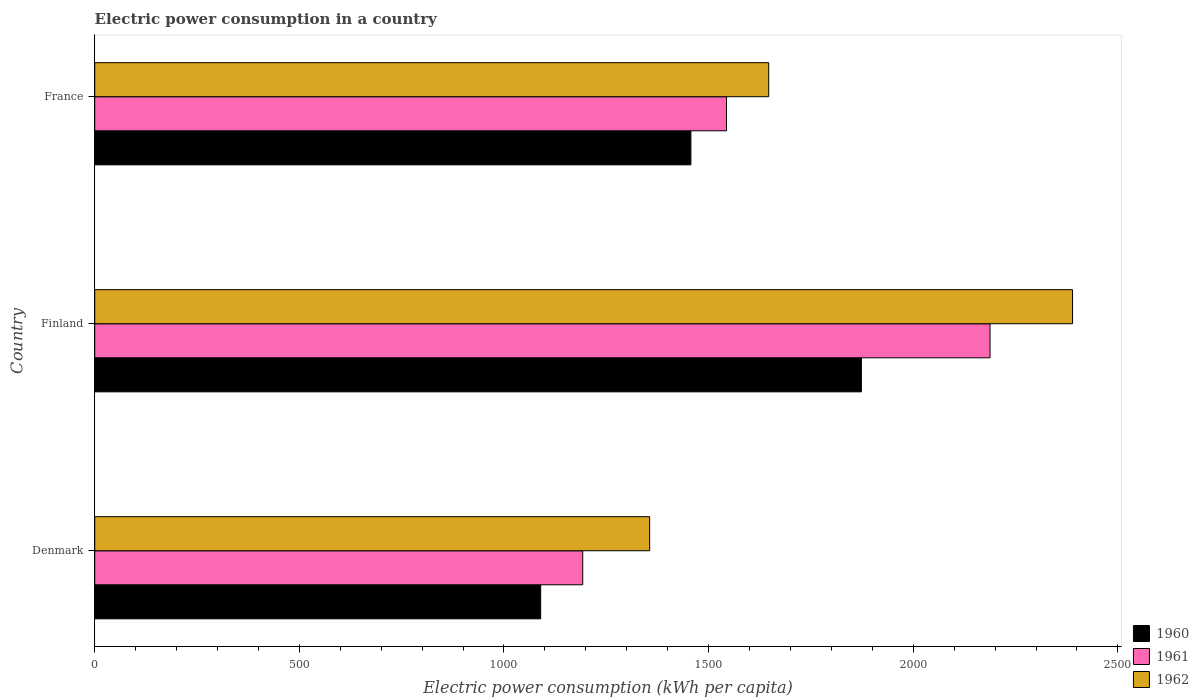How many different coloured bars are there?
Offer a very short reply. 3. How many bars are there on the 2nd tick from the top?
Ensure brevity in your answer.  3. How many bars are there on the 3rd tick from the bottom?
Offer a very short reply. 3. What is the label of the 2nd group of bars from the top?
Make the answer very short. Finland. In how many cases, is the number of bars for a given country not equal to the number of legend labels?
Keep it short and to the point. 0. What is the electric power consumption in in 1962 in Finland?
Your answer should be very brief. 2389.21. Across all countries, what is the maximum electric power consumption in in 1961?
Your response must be concise. 2187.62. Across all countries, what is the minimum electric power consumption in in 1961?
Make the answer very short. 1192.41. In which country was the electric power consumption in in 1961 minimum?
Keep it short and to the point. Denmark. What is the total electric power consumption in in 1960 in the graph?
Your answer should be very brief. 4419.6. What is the difference between the electric power consumption in in 1962 in Finland and that in France?
Your answer should be very brief. 742.38. What is the difference between the electric power consumption in in 1960 in France and the electric power consumption in in 1962 in Finland?
Offer a very short reply. -932.52. What is the average electric power consumption in in 1960 per country?
Make the answer very short. 1473.2. What is the difference between the electric power consumption in in 1961 and electric power consumption in in 1962 in France?
Your answer should be very brief. -103.12. In how many countries, is the electric power consumption in in 1962 greater than 1000 kWh per capita?
Provide a short and direct response. 3. What is the ratio of the electric power consumption in in 1960 in Denmark to that in France?
Give a very brief answer. 0.75. Is the electric power consumption in in 1962 in Finland less than that in France?
Offer a terse response. No. What is the difference between the highest and the second highest electric power consumption in in 1960?
Ensure brevity in your answer.  416.6. What is the difference between the highest and the lowest electric power consumption in in 1960?
Ensure brevity in your answer.  783.68. Is the sum of the electric power consumption in in 1961 in Denmark and France greater than the maximum electric power consumption in in 1960 across all countries?
Your answer should be compact. Yes. What does the 3rd bar from the top in France represents?
Offer a terse response. 1960. Is it the case that in every country, the sum of the electric power consumption in in 1960 and electric power consumption in in 1961 is greater than the electric power consumption in in 1962?
Make the answer very short. Yes. How many bars are there?
Your answer should be compact. 9. Are all the bars in the graph horizontal?
Offer a terse response. Yes. Does the graph contain grids?
Offer a terse response. No. What is the title of the graph?
Provide a succinct answer. Electric power consumption in a country. Does "1973" appear as one of the legend labels in the graph?
Your answer should be very brief. No. What is the label or title of the X-axis?
Ensure brevity in your answer.  Electric power consumption (kWh per capita). What is the Electric power consumption (kWh per capita) of 1960 in Denmark?
Provide a succinct answer. 1089.61. What is the Electric power consumption (kWh per capita) of 1961 in Denmark?
Provide a short and direct response. 1192.41. What is the Electric power consumption (kWh per capita) in 1962 in Denmark?
Your response must be concise. 1355.93. What is the Electric power consumption (kWh per capita) of 1960 in Finland?
Your answer should be very brief. 1873.29. What is the Electric power consumption (kWh per capita) of 1961 in Finland?
Provide a succinct answer. 2187.62. What is the Electric power consumption (kWh per capita) of 1962 in Finland?
Give a very brief answer. 2389.21. What is the Electric power consumption (kWh per capita) of 1960 in France?
Provide a short and direct response. 1456.69. What is the Electric power consumption (kWh per capita) in 1961 in France?
Your answer should be very brief. 1543.71. What is the Electric power consumption (kWh per capita) in 1962 in France?
Your answer should be very brief. 1646.83. Across all countries, what is the maximum Electric power consumption (kWh per capita) in 1960?
Offer a terse response. 1873.29. Across all countries, what is the maximum Electric power consumption (kWh per capita) of 1961?
Provide a succinct answer. 2187.62. Across all countries, what is the maximum Electric power consumption (kWh per capita) of 1962?
Give a very brief answer. 2389.21. Across all countries, what is the minimum Electric power consumption (kWh per capita) of 1960?
Provide a succinct answer. 1089.61. Across all countries, what is the minimum Electric power consumption (kWh per capita) of 1961?
Offer a terse response. 1192.41. Across all countries, what is the minimum Electric power consumption (kWh per capita) of 1962?
Give a very brief answer. 1355.93. What is the total Electric power consumption (kWh per capita) of 1960 in the graph?
Your answer should be compact. 4419.6. What is the total Electric power consumption (kWh per capita) in 1961 in the graph?
Ensure brevity in your answer.  4923.74. What is the total Electric power consumption (kWh per capita) in 1962 in the graph?
Offer a terse response. 5391.97. What is the difference between the Electric power consumption (kWh per capita) in 1960 in Denmark and that in Finland?
Provide a short and direct response. -783.68. What is the difference between the Electric power consumption (kWh per capita) of 1961 in Denmark and that in Finland?
Ensure brevity in your answer.  -995.22. What is the difference between the Electric power consumption (kWh per capita) in 1962 in Denmark and that in Finland?
Your answer should be compact. -1033.28. What is the difference between the Electric power consumption (kWh per capita) of 1960 in Denmark and that in France?
Offer a very short reply. -367.08. What is the difference between the Electric power consumption (kWh per capita) in 1961 in Denmark and that in France?
Keep it short and to the point. -351.31. What is the difference between the Electric power consumption (kWh per capita) in 1962 in Denmark and that in France?
Your answer should be compact. -290.9. What is the difference between the Electric power consumption (kWh per capita) in 1960 in Finland and that in France?
Your response must be concise. 416.6. What is the difference between the Electric power consumption (kWh per capita) in 1961 in Finland and that in France?
Ensure brevity in your answer.  643.91. What is the difference between the Electric power consumption (kWh per capita) of 1962 in Finland and that in France?
Provide a short and direct response. 742.38. What is the difference between the Electric power consumption (kWh per capita) in 1960 in Denmark and the Electric power consumption (kWh per capita) in 1961 in Finland?
Provide a short and direct response. -1098.01. What is the difference between the Electric power consumption (kWh per capita) in 1960 in Denmark and the Electric power consumption (kWh per capita) in 1962 in Finland?
Offer a terse response. -1299.6. What is the difference between the Electric power consumption (kWh per capita) of 1961 in Denmark and the Electric power consumption (kWh per capita) of 1962 in Finland?
Your answer should be very brief. -1196.8. What is the difference between the Electric power consumption (kWh per capita) of 1960 in Denmark and the Electric power consumption (kWh per capita) of 1961 in France?
Ensure brevity in your answer.  -454.1. What is the difference between the Electric power consumption (kWh per capita) of 1960 in Denmark and the Electric power consumption (kWh per capita) of 1962 in France?
Offer a very short reply. -557.22. What is the difference between the Electric power consumption (kWh per capita) of 1961 in Denmark and the Electric power consumption (kWh per capita) of 1962 in France?
Offer a very short reply. -454.43. What is the difference between the Electric power consumption (kWh per capita) in 1960 in Finland and the Electric power consumption (kWh per capita) in 1961 in France?
Provide a short and direct response. 329.58. What is the difference between the Electric power consumption (kWh per capita) of 1960 in Finland and the Electric power consumption (kWh per capita) of 1962 in France?
Keep it short and to the point. 226.46. What is the difference between the Electric power consumption (kWh per capita) of 1961 in Finland and the Electric power consumption (kWh per capita) of 1962 in France?
Offer a very short reply. 540.79. What is the average Electric power consumption (kWh per capita) in 1960 per country?
Ensure brevity in your answer.  1473.2. What is the average Electric power consumption (kWh per capita) of 1961 per country?
Offer a very short reply. 1641.25. What is the average Electric power consumption (kWh per capita) of 1962 per country?
Give a very brief answer. 1797.32. What is the difference between the Electric power consumption (kWh per capita) in 1960 and Electric power consumption (kWh per capita) in 1961 in Denmark?
Provide a short and direct response. -102.79. What is the difference between the Electric power consumption (kWh per capita) in 1960 and Electric power consumption (kWh per capita) in 1962 in Denmark?
Your response must be concise. -266.32. What is the difference between the Electric power consumption (kWh per capita) of 1961 and Electric power consumption (kWh per capita) of 1962 in Denmark?
Make the answer very short. -163.53. What is the difference between the Electric power consumption (kWh per capita) of 1960 and Electric power consumption (kWh per capita) of 1961 in Finland?
Your answer should be compact. -314.33. What is the difference between the Electric power consumption (kWh per capita) in 1960 and Electric power consumption (kWh per capita) in 1962 in Finland?
Give a very brief answer. -515.92. What is the difference between the Electric power consumption (kWh per capita) of 1961 and Electric power consumption (kWh per capita) of 1962 in Finland?
Give a very brief answer. -201.59. What is the difference between the Electric power consumption (kWh per capita) of 1960 and Electric power consumption (kWh per capita) of 1961 in France?
Keep it short and to the point. -87.02. What is the difference between the Electric power consumption (kWh per capita) in 1960 and Electric power consumption (kWh per capita) in 1962 in France?
Provide a succinct answer. -190.14. What is the difference between the Electric power consumption (kWh per capita) in 1961 and Electric power consumption (kWh per capita) in 1962 in France?
Keep it short and to the point. -103.12. What is the ratio of the Electric power consumption (kWh per capita) in 1960 in Denmark to that in Finland?
Make the answer very short. 0.58. What is the ratio of the Electric power consumption (kWh per capita) in 1961 in Denmark to that in Finland?
Ensure brevity in your answer.  0.55. What is the ratio of the Electric power consumption (kWh per capita) in 1962 in Denmark to that in Finland?
Keep it short and to the point. 0.57. What is the ratio of the Electric power consumption (kWh per capita) in 1960 in Denmark to that in France?
Your answer should be very brief. 0.75. What is the ratio of the Electric power consumption (kWh per capita) of 1961 in Denmark to that in France?
Provide a short and direct response. 0.77. What is the ratio of the Electric power consumption (kWh per capita) in 1962 in Denmark to that in France?
Your response must be concise. 0.82. What is the ratio of the Electric power consumption (kWh per capita) in 1960 in Finland to that in France?
Offer a terse response. 1.29. What is the ratio of the Electric power consumption (kWh per capita) in 1961 in Finland to that in France?
Your answer should be very brief. 1.42. What is the ratio of the Electric power consumption (kWh per capita) in 1962 in Finland to that in France?
Make the answer very short. 1.45. What is the difference between the highest and the second highest Electric power consumption (kWh per capita) in 1960?
Your answer should be very brief. 416.6. What is the difference between the highest and the second highest Electric power consumption (kWh per capita) in 1961?
Your answer should be compact. 643.91. What is the difference between the highest and the second highest Electric power consumption (kWh per capita) of 1962?
Provide a short and direct response. 742.38. What is the difference between the highest and the lowest Electric power consumption (kWh per capita) of 1960?
Your response must be concise. 783.68. What is the difference between the highest and the lowest Electric power consumption (kWh per capita) in 1961?
Your response must be concise. 995.22. What is the difference between the highest and the lowest Electric power consumption (kWh per capita) in 1962?
Make the answer very short. 1033.28. 